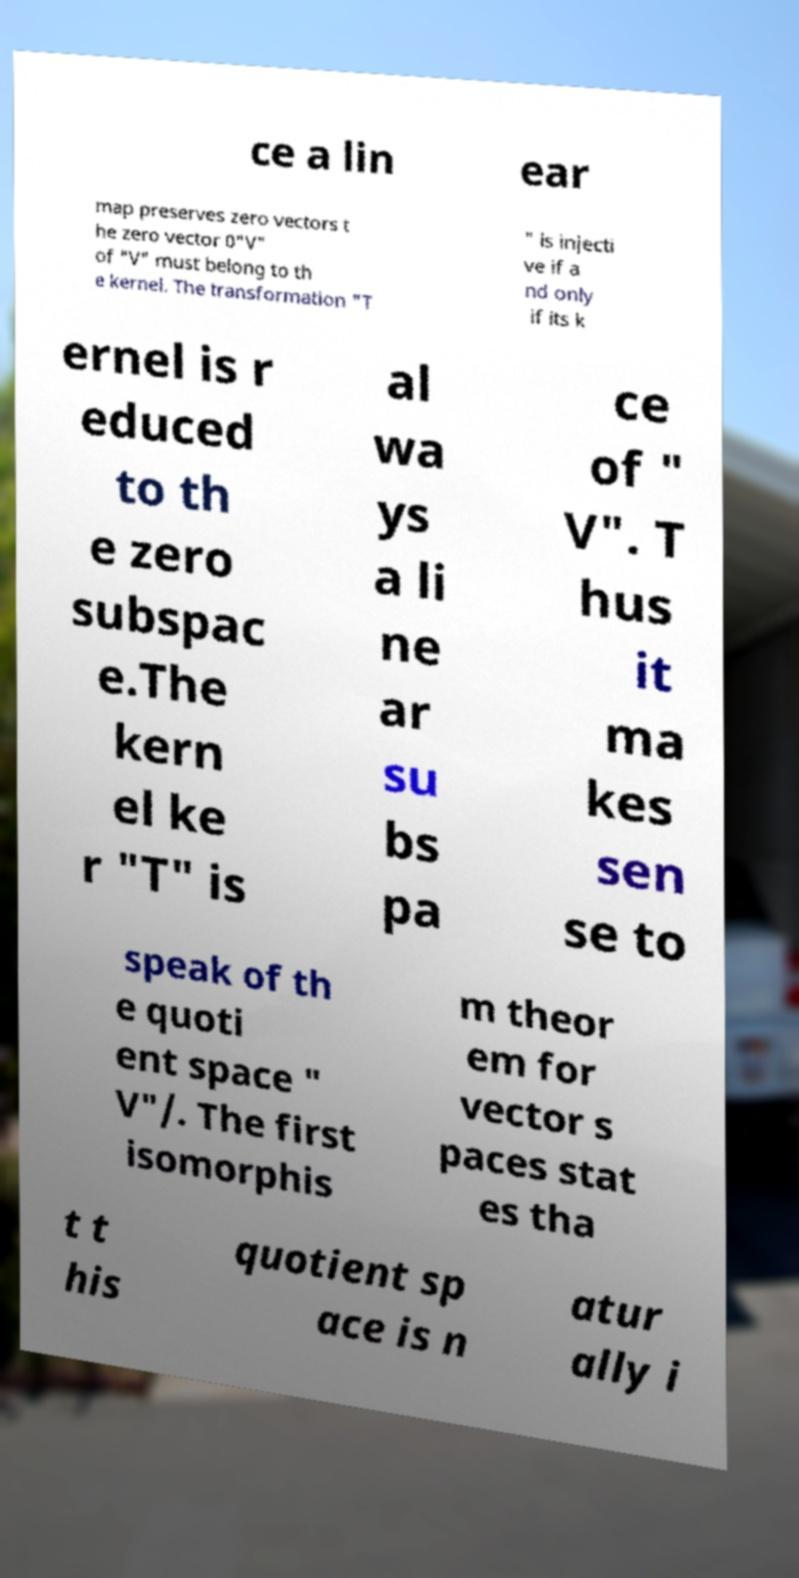Please read and relay the text visible in this image. What does it say? ce a lin ear map preserves zero vectors t he zero vector 0"V" of "V" must belong to th e kernel. The transformation "T " is injecti ve if a nd only if its k ernel is r educed to th e zero subspac e.The kern el ke r "T" is al wa ys a li ne ar su bs pa ce of " V". T hus it ma kes sen se to speak of th e quoti ent space " V"/. The first isomorphis m theor em for vector s paces stat es tha t t his quotient sp ace is n atur ally i 